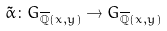Convert formula to latex. <formula><loc_0><loc_0><loc_500><loc_500>\tilde { \alpha } \colon G _ { \overline { \mathbb { Q } } ( x , y ) } \rightarrow G _ { \overline { \mathbb { Q } } ( x , y ) }</formula> 